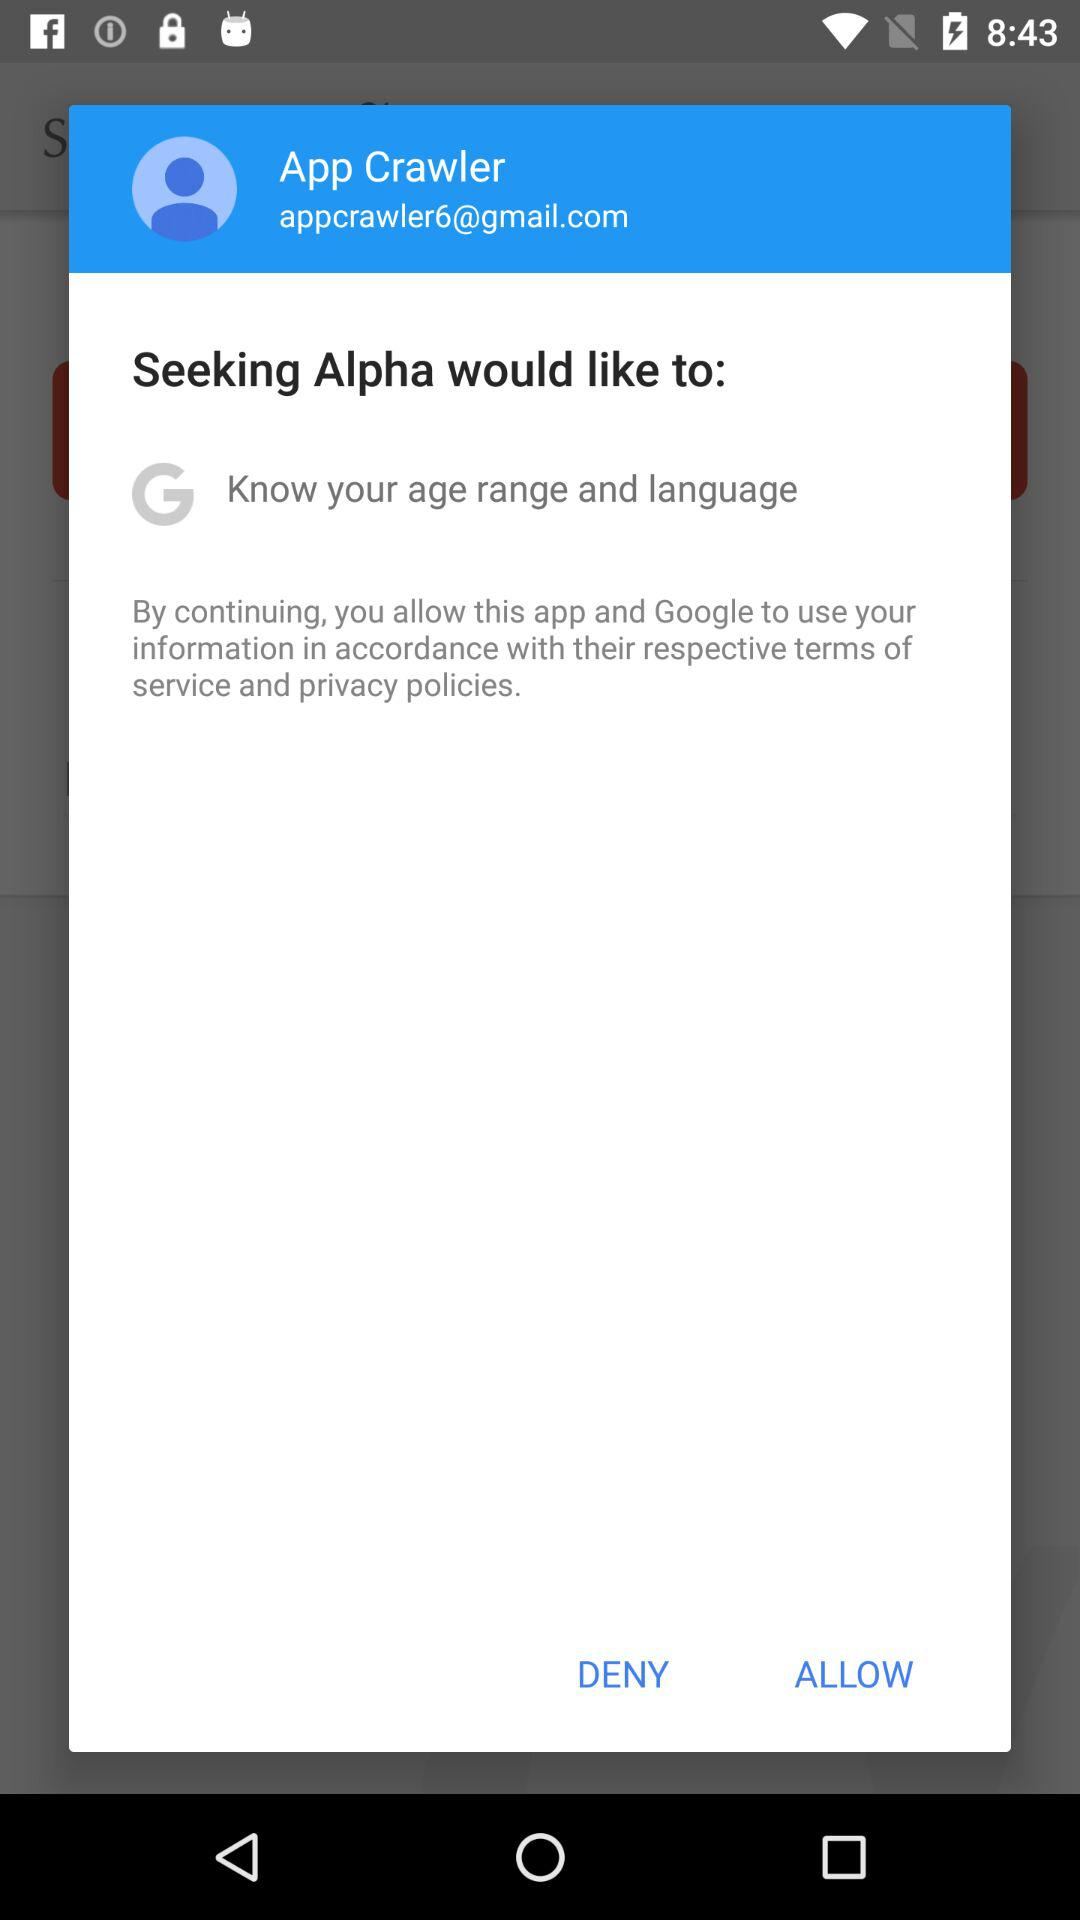What is the username? The username is "App Crawler". 